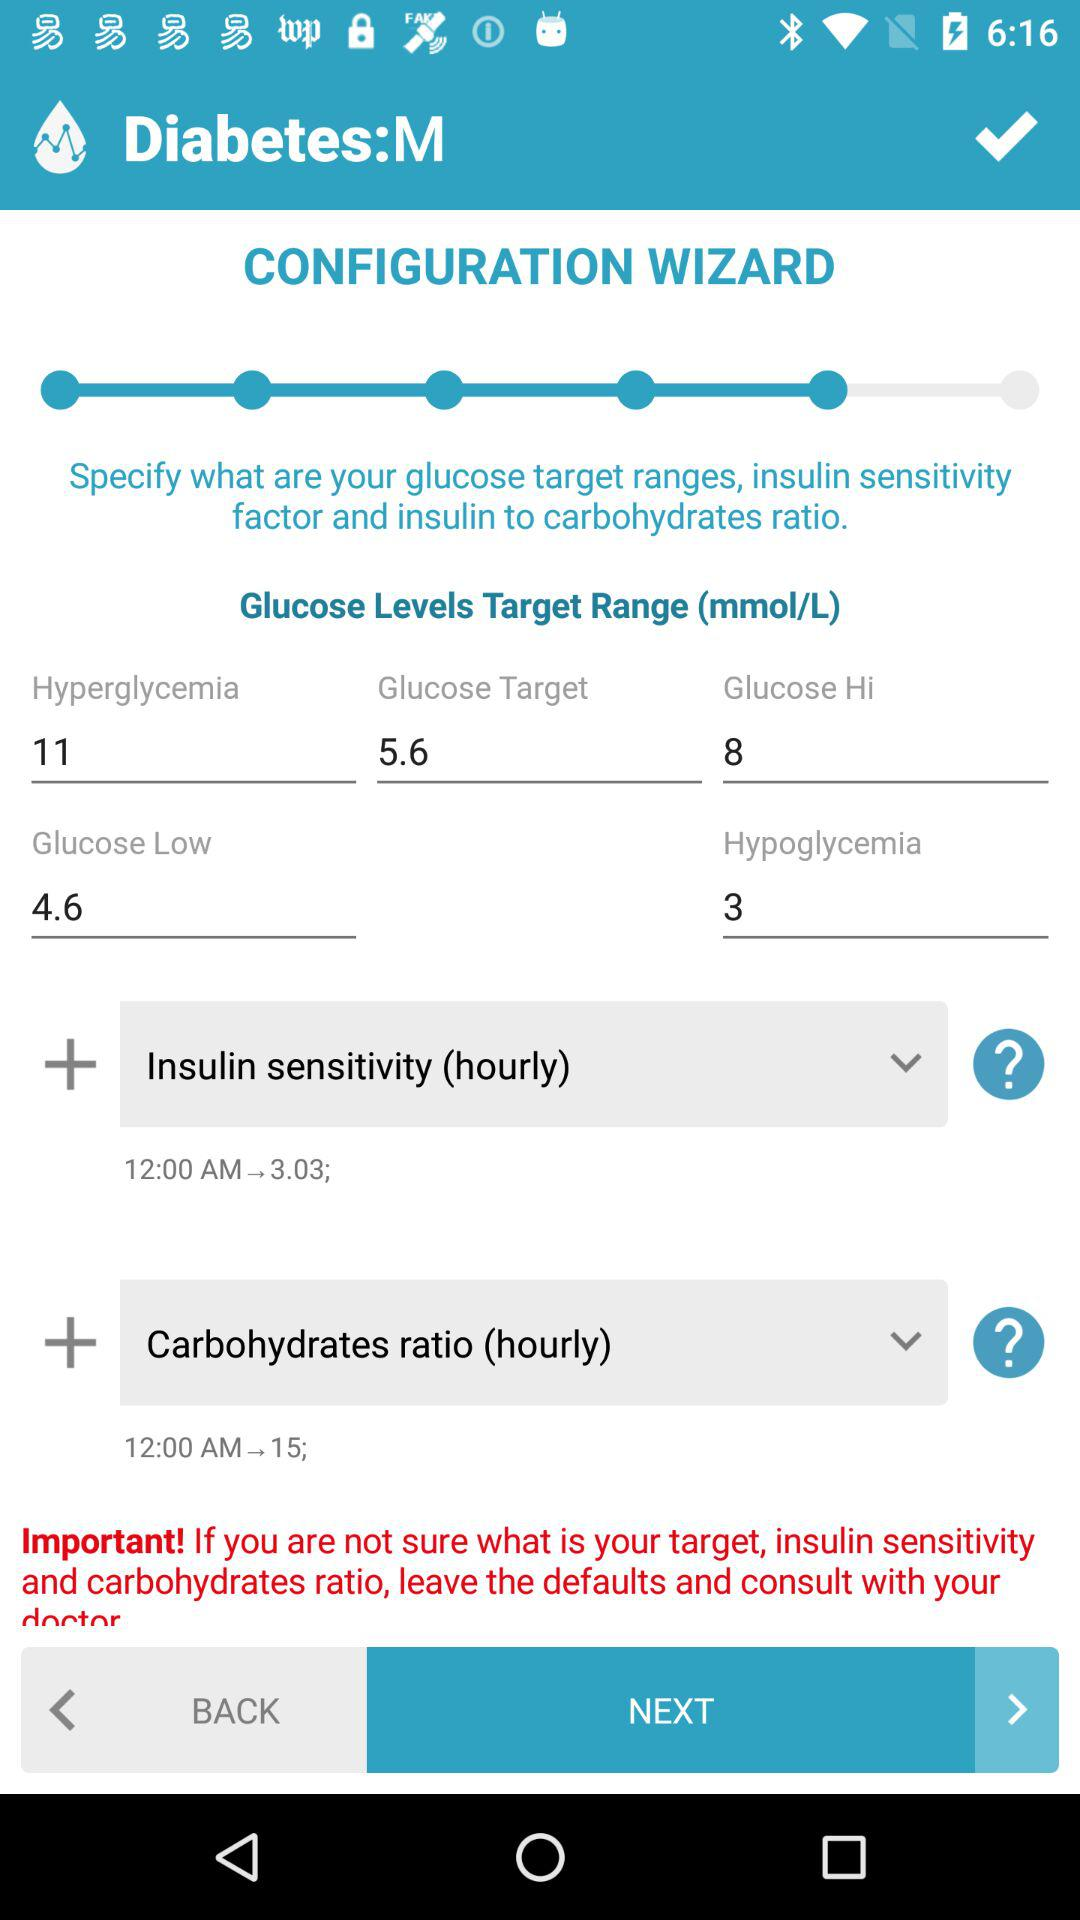What is the high glucose value? The high glucose value is 8. 